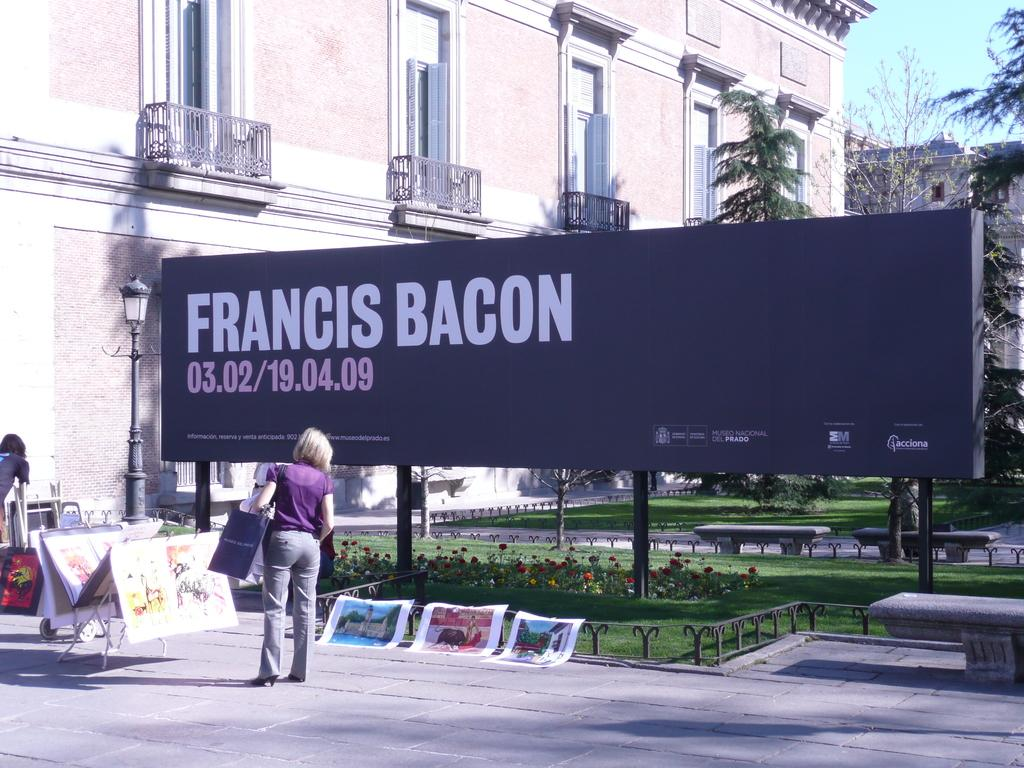<image>
Create a compact narrative representing the image presented. Some artwork is arranged below a billboard saying Francis Bacon. 